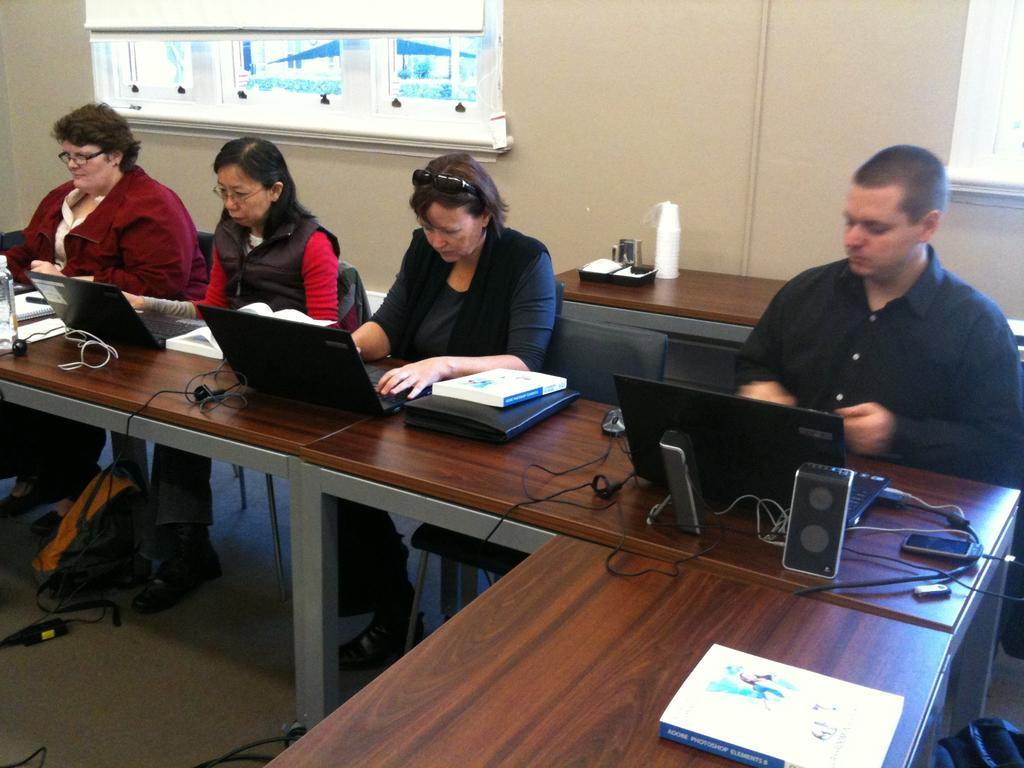How would you summarize this image in a sentence or two? In this image I can see the four people are sitting. In-front of them there is a laptop,speakers,books,wires on the table. And we can also see the bag on the floor. At the back there's a wall with window blind. 